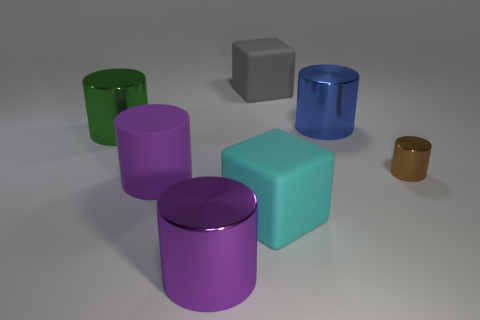Subtract 2 cylinders. How many cylinders are left? 3 Subtract all green cylinders. How many cylinders are left? 4 Subtract all large blue cylinders. How many cylinders are left? 4 Subtract all yellow cylinders. Subtract all green blocks. How many cylinders are left? 5 Add 2 large purple matte objects. How many objects exist? 9 Subtract all blocks. How many objects are left? 5 Add 4 cyan objects. How many cyan objects are left? 5 Add 7 small brown matte cylinders. How many small brown matte cylinders exist? 7 Subtract 1 brown cylinders. How many objects are left? 6 Subtract all cyan matte cubes. Subtract all blue metallic cylinders. How many objects are left? 5 